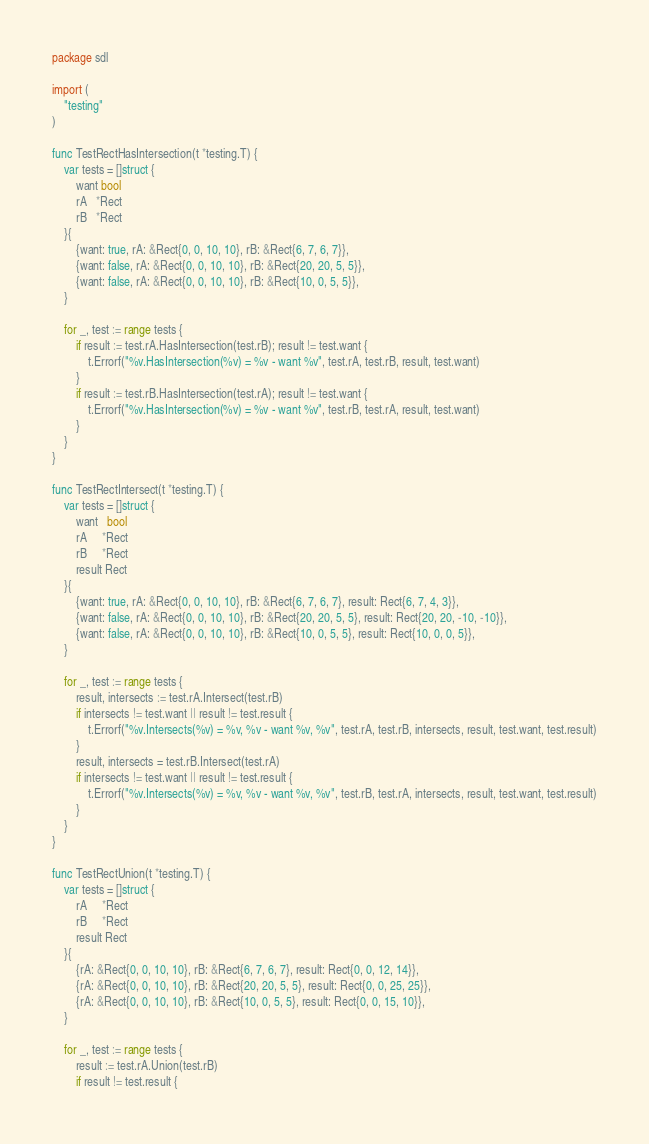Convert code to text. <code><loc_0><loc_0><loc_500><loc_500><_Go_>package sdl

import (
	"testing"
)

func TestRectHasIntersection(t *testing.T) {
	var tests = []struct {
		want bool
		rA   *Rect
		rB   *Rect
	}{
		{want: true, rA: &Rect{0, 0, 10, 10}, rB: &Rect{6, 7, 6, 7}},
		{want: false, rA: &Rect{0, 0, 10, 10}, rB: &Rect{20, 20, 5, 5}},
		{want: false, rA: &Rect{0, 0, 10, 10}, rB: &Rect{10, 0, 5, 5}},
	}

	for _, test := range tests {
		if result := test.rA.HasIntersection(test.rB); result != test.want {
			t.Errorf("%v.HasIntersection(%v) = %v - want %v", test.rA, test.rB, result, test.want)
		}
		if result := test.rB.HasIntersection(test.rA); result != test.want {
			t.Errorf("%v.HasIntersection(%v) = %v - want %v", test.rB, test.rA, result, test.want)
		}
	}
}

func TestRectIntersect(t *testing.T) {
	var tests = []struct {
		want   bool
		rA     *Rect
		rB     *Rect
		result Rect
	}{
		{want: true, rA: &Rect{0, 0, 10, 10}, rB: &Rect{6, 7, 6, 7}, result: Rect{6, 7, 4, 3}},
		{want: false, rA: &Rect{0, 0, 10, 10}, rB: &Rect{20, 20, 5, 5}, result: Rect{20, 20, -10, -10}},
		{want: false, rA: &Rect{0, 0, 10, 10}, rB: &Rect{10, 0, 5, 5}, result: Rect{10, 0, 0, 5}},
	}

	for _, test := range tests {
		result, intersects := test.rA.Intersect(test.rB)
		if intersects != test.want || result != test.result {
			t.Errorf("%v.Intersects(%v) = %v, %v - want %v, %v", test.rA, test.rB, intersects, result, test.want, test.result)
		}
		result, intersects = test.rB.Intersect(test.rA)
		if intersects != test.want || result != test.result {
			t.Errorf("%v.Intersects(%v) = %v, %v - want %v, %v", test.rB, test.rA, intersects, result, test.want, test.result)
		}
	}
}

func TestRectUnion(t *testing.T) {
	var tests = []struct {
		rA     *Rect
		rB     *Rect
		result Rect
	}{
		{rA: &Rect{0, 0, 10, 10}, rB: &Rect{6, 7, 6, 7}, result: Rect{0, 0, 12, 14}},
		{rA: &Rect{0, 0, 10, 10}, rB: &Rect{20, 20, 5, 5}, result: Rect{0, 0, 25, 25}},
		{rA: &Rect{0, 0, 10, 10}, rB: &Rect{10, 0, 5, 5}, result: Rect{0, 0, 15, 10}},
	}

	for _, test := range tests {
		result := test.rA.Union(test.rB)
		if result != test.result {</code> 